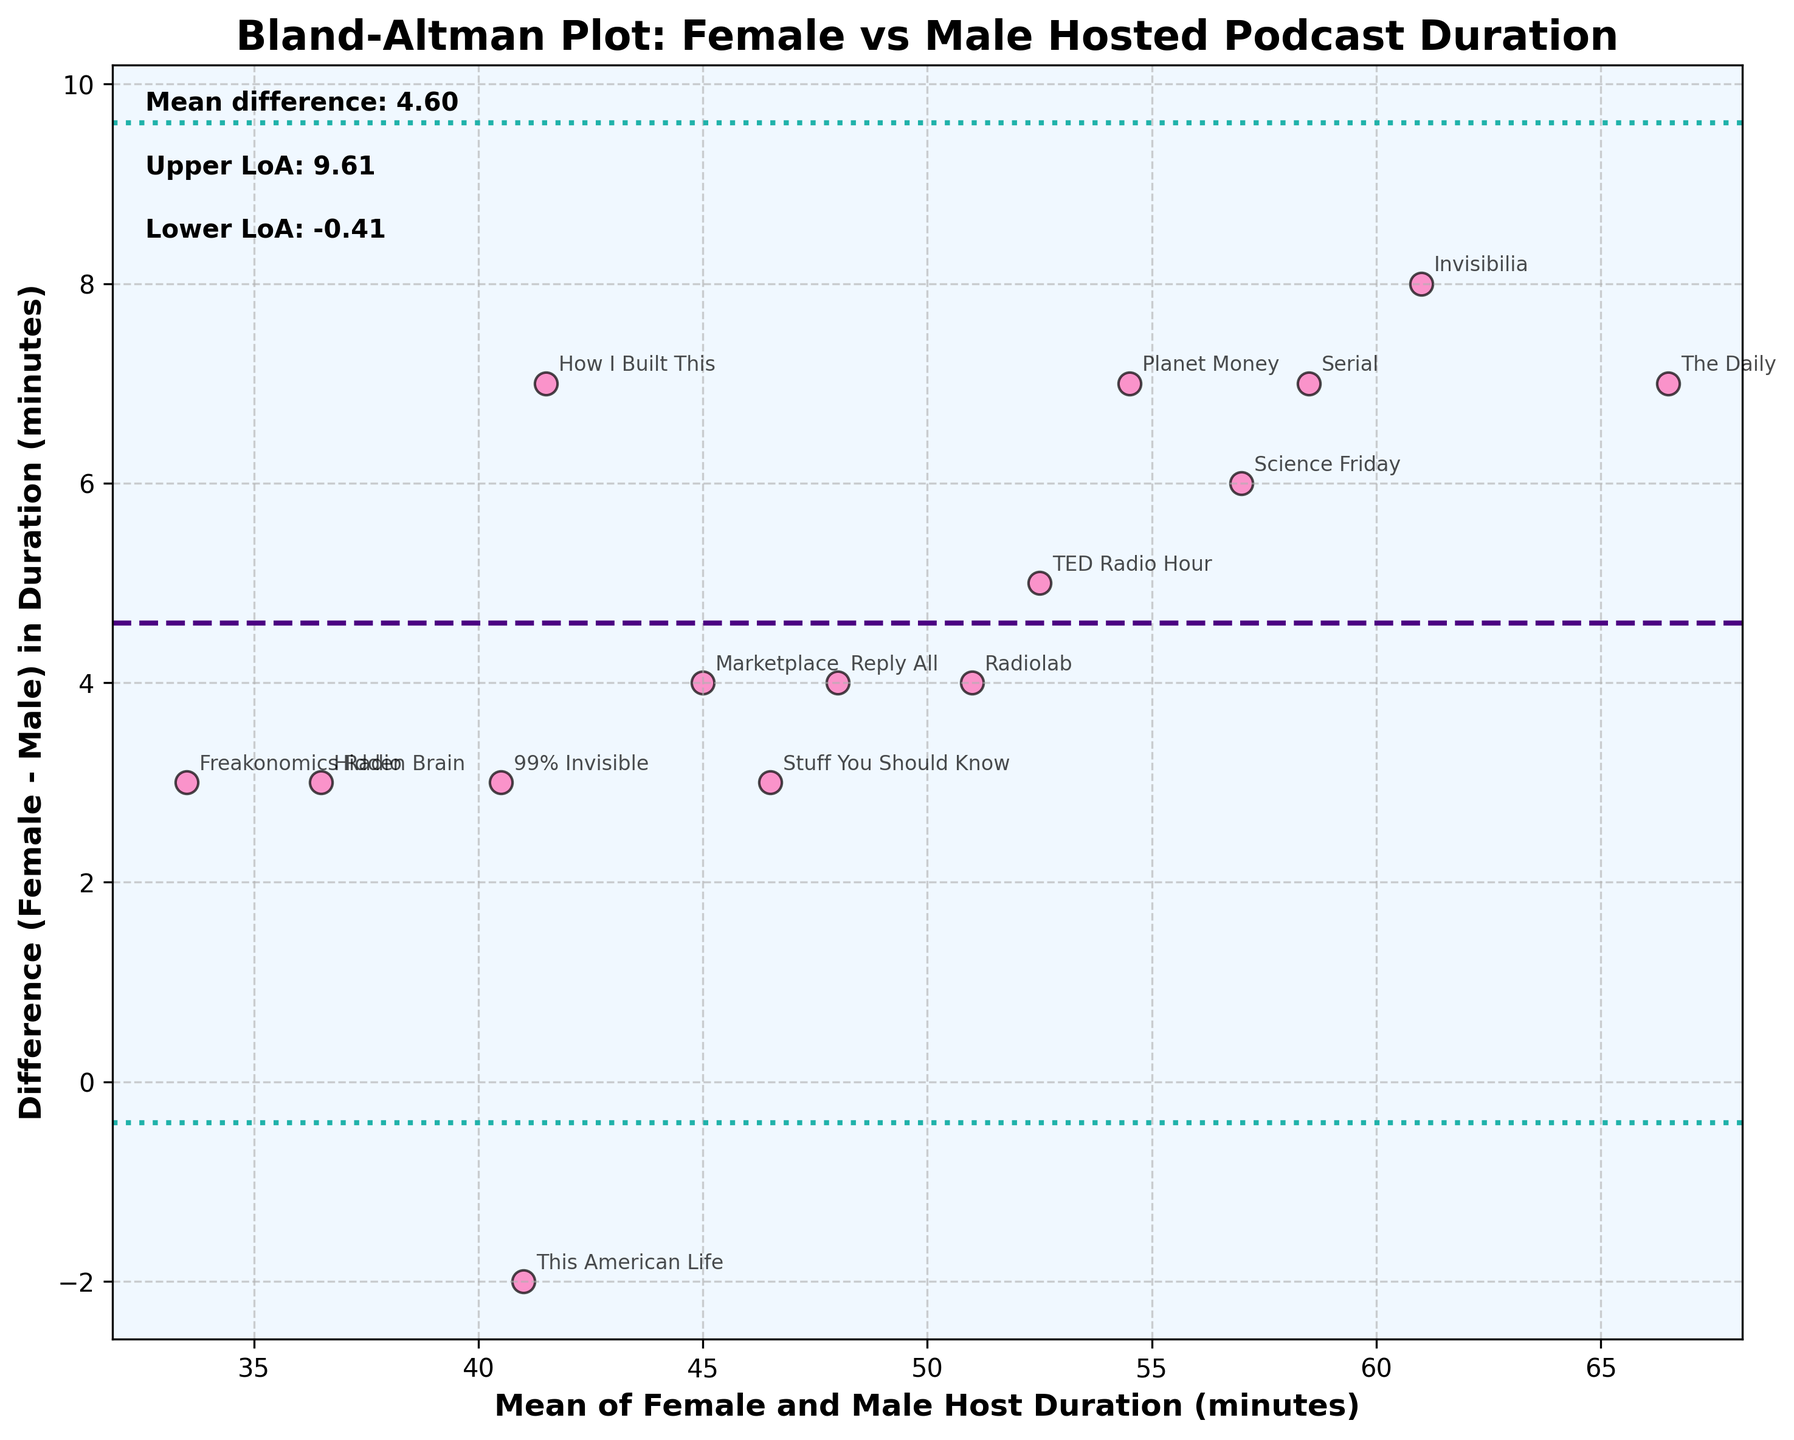What is the title of the figure? The title of the figure can be found at the top of the plot. It states the purpose of the plot.
Answer: Bland-Altman Plot: Female vs Male Hosted Podcast Duration How many podcast names are annotated in the plot? Each podcast has its name annotated next to the corresponding data point in the scatter plot. Counting these names will give the total.
Answer: 15 What do the horizontal dashed and dotted lines represent? The dashed line in the middle represents the mean difference between female and male host durations. The dotted lines above and below this line represent the upper and lower limits of agreement (LoA).
Answer: Mean difference, Upper and Lower LoA What color is used to plot the data points? The data points can be identified by the visual appearance in the plot. The color used for them is specific.
Answer: Pink What is the value of the mean difference? The mean difference is annotated in text at the top-left corner of the plot. The value is explicitly provided there.
Answer: -4.07 What are the upper and lower limits of agreement? These values are also annotated in text at the top-left corner of the plot. They show how much spread there is from the mean difference.
Answer: Upper LoA: 0.80, Lower LoA: -8.93 Which podcasts have durations where females host significantly longer than males? By looking at the data points that have a large positive difference and the corresponding podcast names, we can identify these podcasts.
Answer: "Planet Money," "Invisibilia," "The Daily," "How I Built This" How many podcasts show a male host duration longer than the female host duration? Count the number of data points below the zero difference line to find how many have longer durations for male hosts.
Answer: 3 What's the biggest positive difference in duration between female and male hosts? Which podcast does it correspond to? The largest positive difference can be identified by the highest point above the zero difference line. Check the annotated name for this point.
Answer: 7 minutes, "Invisibilia" Why might it be significant that the mean difference is negative? The mean difference being negative indicates that, on average, female-hosted podcasts tend to have shorter durations compared to male-hosted podcasts. This suggests a potential pattern or trend in podcast durations based on the host gender.
Answer: Female-hosted tend to be shorter 